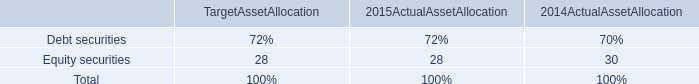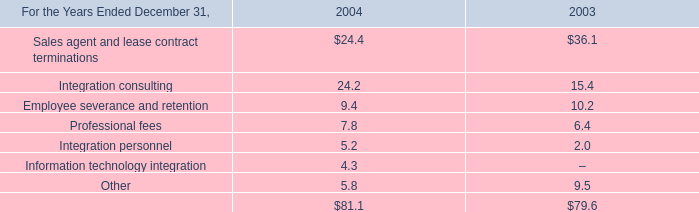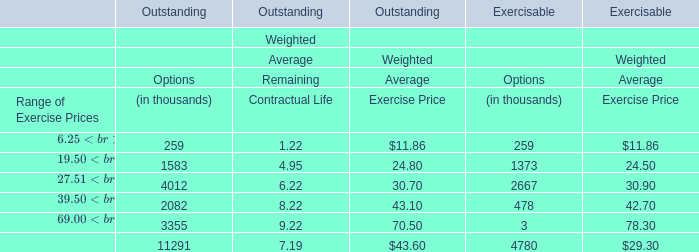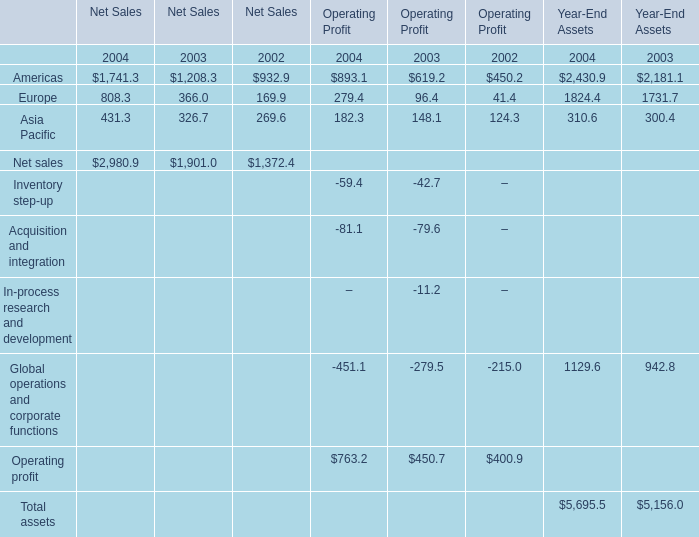What is the Weighted Average Exercise Price for the Range of Exercise Prices $19.50 – $27.50 in terms of Outstanding as As the chart 2 shows? 
Answer: 24.8. 